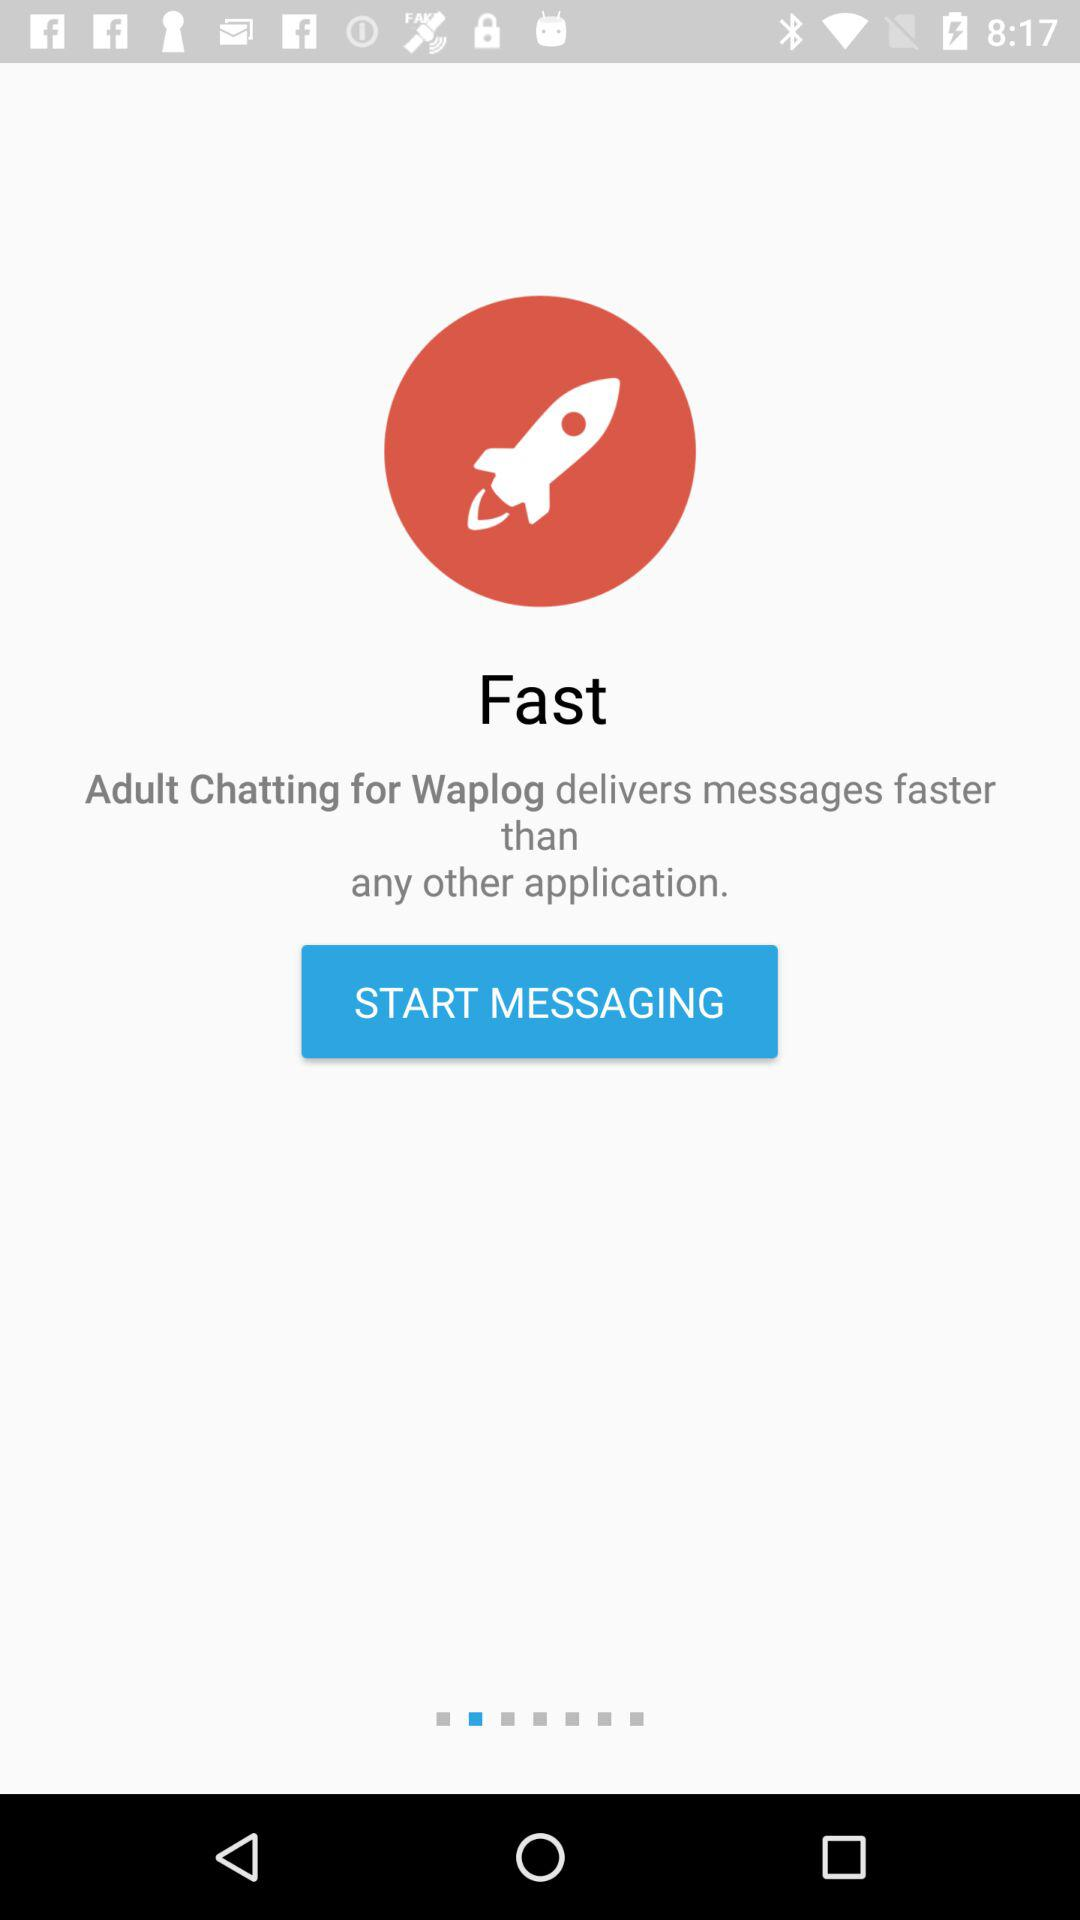What is the application name? The application name is "Fast". 